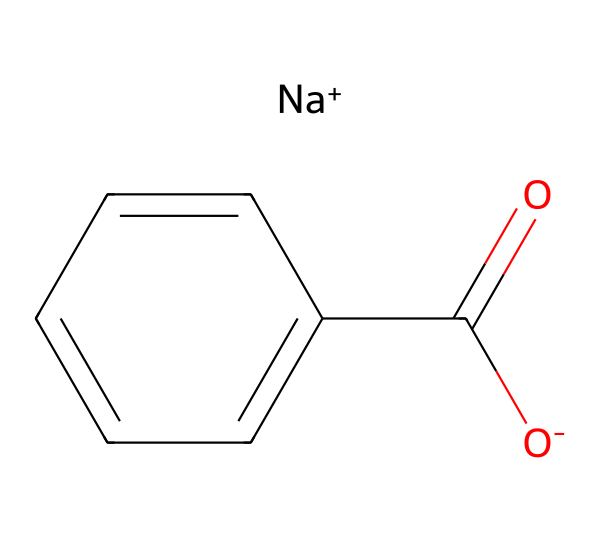What is the molecular formula of sodium benzoate? By analyzing the provided SMILES representation, the molecular components include one sodium (Na), one carbon (C) from the benzoate part, five additional carbon atoms in the benzene ring (totaling six), two oxygen (O) atoms, and one hydrogen (H) from the carboxylate group. Combining these gives us the molecular formula C7H5O2Na.
Answer: C7H5O2Na How many carbon atoms are present in sodium benzoate? From the SMILES structure, we can identify six carbon atoms in total: one in the carboxylate (–C(=O)O) and five in the benzene ring (c1ccccc1).
Answer: 7 What functional group is present in sodium benzoate? The presence of a carboxylate group (–COO–) can be recognized in the structure, identified by the carbon connected to two oxygens, one of which has a negative charge, indicative of its role as a salt.
Answer: carboxylate What type of chemical is sodium benzoate? Sodium benzoate is a food additive and preservative commonly used to inhibit microbial growth. Its structure is indicative of its role in food preservation due to its salt form and organic properties.
Answer: preservative Why does sodium benzoate dissolve well in water? The presence of the sodium cation and the negatively charged carboxylate ion contributes to high solubility in water. The ionic interactions with water molecules facilitate dissociation and solvation.
Answer: ionic What is the charge of the sodium ion in sodium benzoate? By examining the SMILES notation, the sodium ion is denoted as [Na+], indicating it has a positive charge.
Answer: positive In what industries, other than food, is sodium benzoate commonly used? Beyond its role as a food preservative, sodium benzoate is also utilized in various industrial applications, notably in cleaning products, where it is valued for its antibacterial properties.
Answer: industrial cleaning 